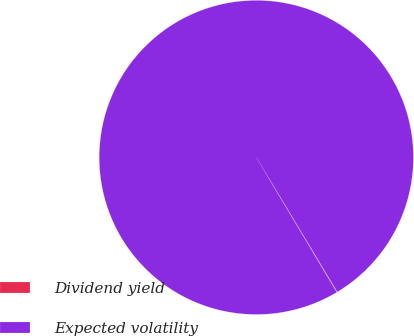<chart> <loc_0><loc_0><loc_500><loc_500><pie_chart><fcel>Dividend yield<fcel>Expected volatility<nl><fcel>0.06%<fcel>99.94%<nl></chart> 